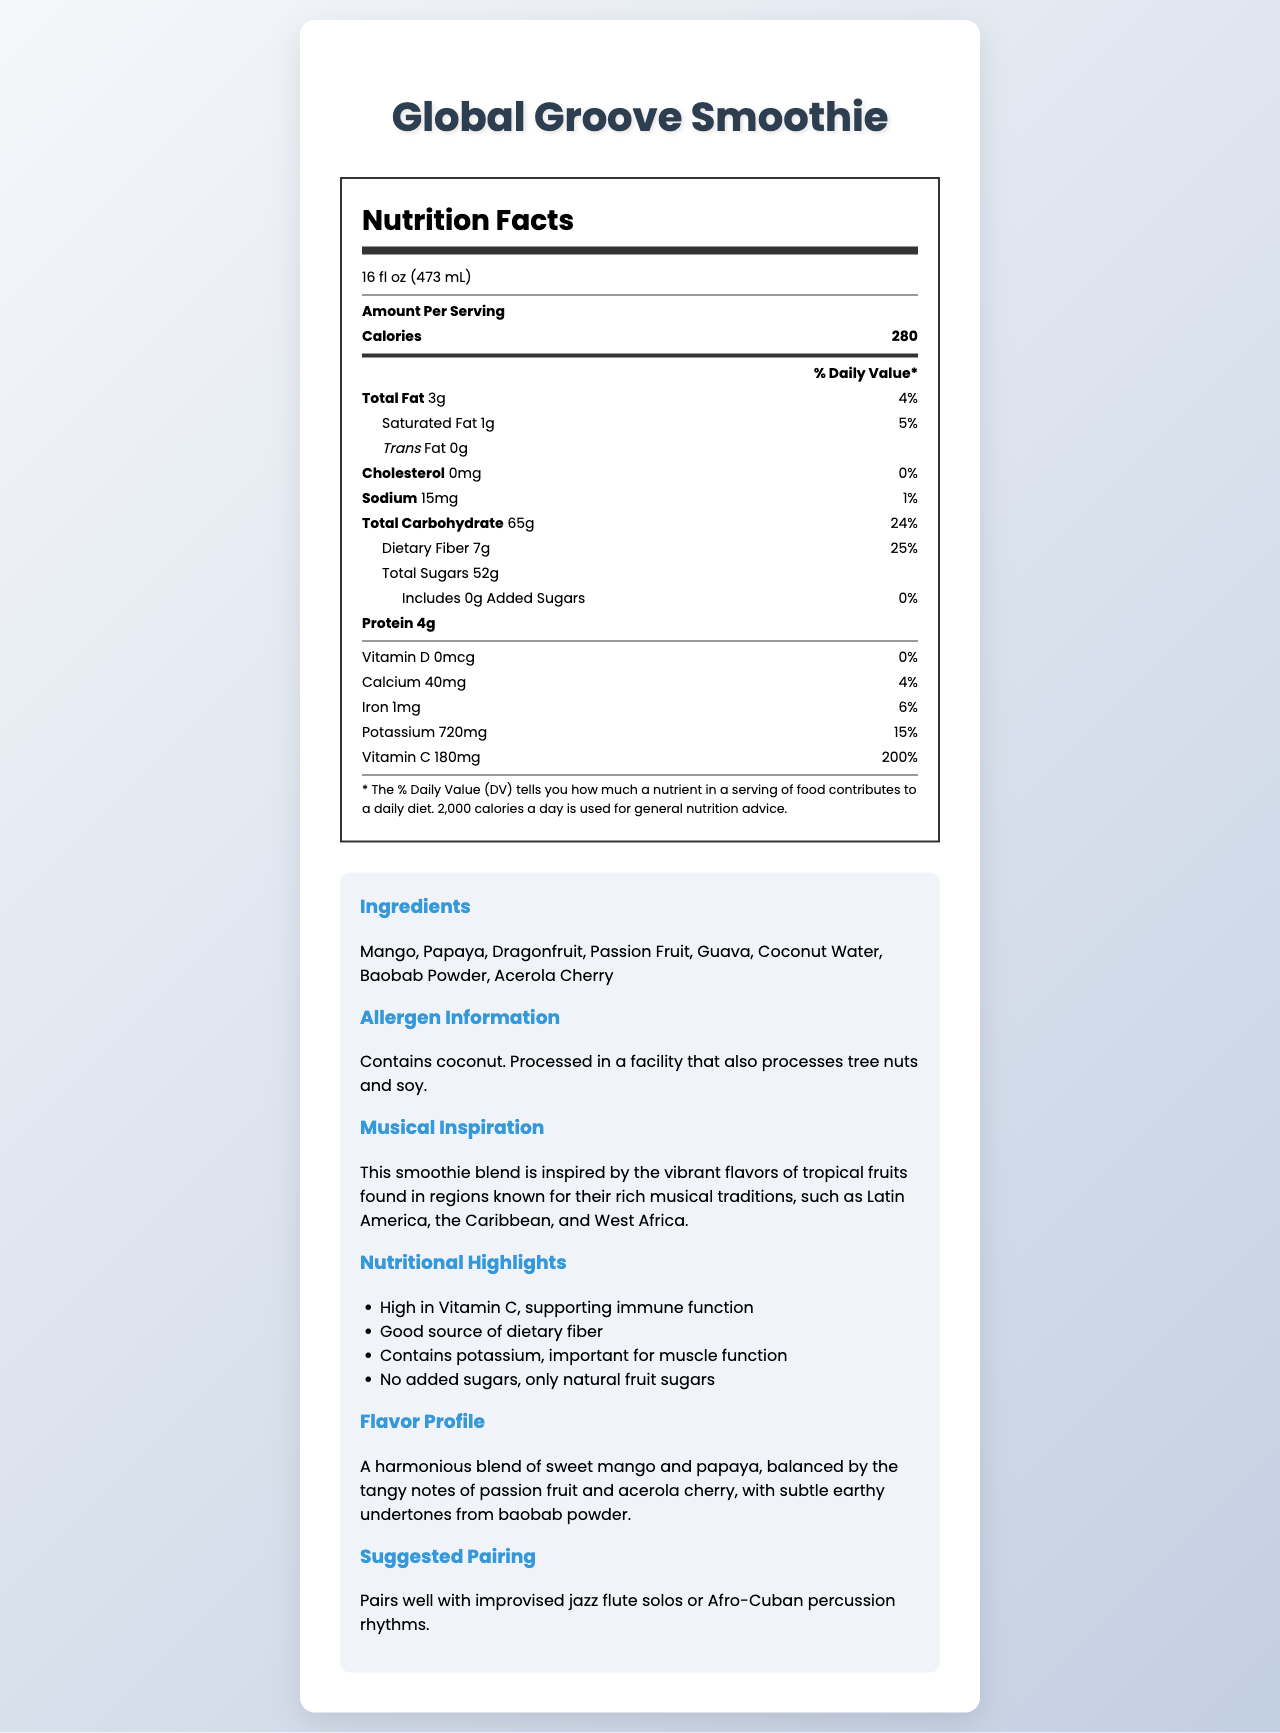what is the serving size of the Global Groove Smoothie? The serving size is clearly stated at the beginning of the document.
Answer: 16 fl oz (473 mL) how many servings are in one container? The document specifies that there is 1 serving per container.
Answer: 1 how many calories are in one serving of the smoothie? The calorie content per serving is listed as 280.
Answer: 280 what is the total fat content in one serving? The total fat content is indicated as 3g.
Answer: 3g does the smoothie contain any trans fat? The document shows 0g of trans fat, indicating none is present.
Answer: No what percentage of Daily Value for Vitamin C does the smoothie provide? The amount of Vitamin C is 180mg, which is 200% of the daily value.
Answer: 200% which nutrient is the smoothie highest in terms of daily value percentage? The Vitamin C content provides 200% of the daily value, which is the highest percentage listed.
Answer: Vitamin C how much potassium is in one serving and what is its Daily Value percentage? The document states that the smoothie contains 720mg of potassium, which accounts for 15% of the daily value.
Answer: 720mg, 15% what are the main ingredients in the Global Groove Smoothie? These ingredients are clearly listed under the ingredients section in the document.
Answer: Mango, Papaya, Dragonfruit, Passion Fruit, Guava, Coconut Water, Baobab Powder, Acerola Cherry does the smoothie contain any cholesterol? The document indicates 0mg of cholesterol, which means it contains none.
Answer: No which of the following is a good source of dietary fiber? A. Mango B. Global Groove Smoothie C. Coconut Water D. Passion Fruit The Global Groove Smoothie is highlighted as a good source of dietary fiber.
Answer: B what describes the flavor profile of the smoothie? A. Spicy and tangy B. Sweet and sour C. Sweet with earthy undertones D. Salty and umami The document describes the flavor profile as a harmonious blend of sweet mango and papaya, balanced by tangy notes of passion fruit and acerola cherry, with subtle earthy undertones.
Answer: C is the smoothie free from added sugars? The document explicitly states that there are 0g of added sugars.
Answer: Yes summarize the main nutritional benefits of the Global Groove Smoothie. The document highlights these main nutritional benefits in the nutritional highlights section, emphasizing the high Vitamin C content, dietary fiber, potassium, and absence of added sugars.
Answer: The Global Groove Smoothie is high in Vitamin C, supporting immune function, is a good source of dietary fiber, contains potassium important for muscle function, and has no added sugars. what is the origin of the musical inspiration for the smoothie? The document mentions the musical inspiration is from regions with rich musical traditions, such as Latin America, the Caribbean, and West Africa, but does not specify an exact origin or influence.
Answer: Cannot be determined what is the suggested musical pairing for the Global Groove Smoothie? The document suggests that the smoothie pairs well with these types of musical performances.
Answer: Improvised jazz flute solos or Afro-Cuban percussion rhythms how much protein does one serving of the smoothie provide? The document lists the protein content as 4g per serving.
Answer: 4g does this smoothie contain any allergens? The document provides allergen information indicating that it contains coconut and is processed in a facility with tree nuts and soy.
Answer: Contains coconut. Processed in a facility that also processes tree nuts and soy. 